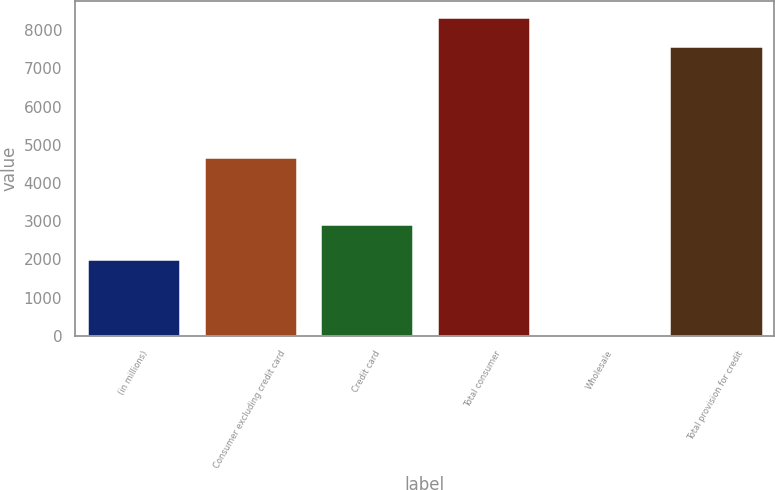Convert chart. <chart><loc_0><loc_0><loc_500><loc_500><bar_chart><fcel>(in millions)<fcel>Consumer excluding credit card<fcel>Credit card<fcel>Total consumer<fcel>Wholesale<fcel>Total provision for credit<nl><fcel>2011<fcel>4672<fcel>2925<fcel>8331.4<fcel>23<fcel>7574<nl></chart> 